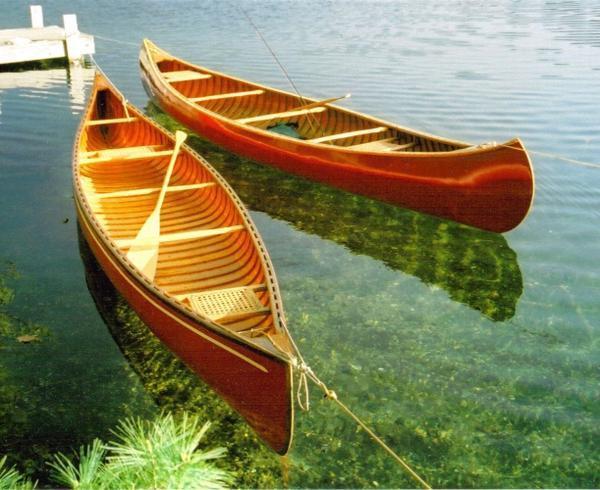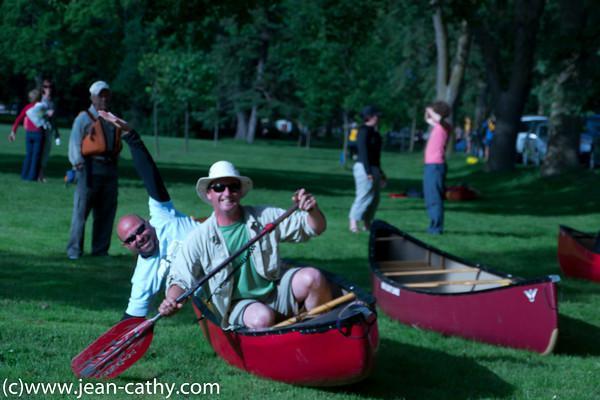The first image is the image on the left, the second image is the image on the right. Assess this claim about the two images: "In at least one image, canoes are docked at the water edge with no people present.". Correct or not? Answer yes or no. Yes. 